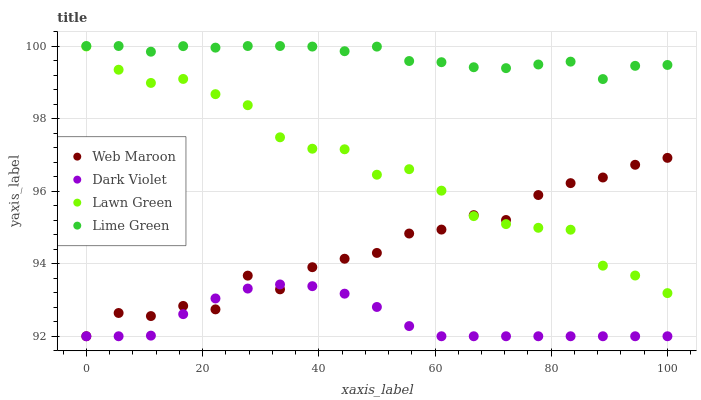Does Dark Violet have the minimum area under the curve?
Answer yes or no. Yes. Does Lime Green have the maximum area under the curve?
Answer yes or no. Yes. Does Lawn Green have the minimum area under the curve?
Answer yes or no. No. Does Lawn Green have the maximum area under the curve?
Answer yes or no. No. Is Dark Violet the smoothest?
Answer yes or no. Yes. Is Web Maroon the roughest?
Answer yes or no. Yes. Is Lawn Green the smoothest?
Answer yes or no. No. Is Lawn Green the roughest?
Answer yes or no. No. Does Web Maroon have the lowest value?
Answer yes or no. Yes. Does Lawn Green have the lowest value?
Answer yes or no. No. Does Lime Green have the highest value?
Answer yes or no. Yes. Does Lawn Green have the highest value?
Answer yes or no. No. Is Dark Violet less than Lime Green?
Answer yes or no. Yes. Is Lime Green greater than Dark Violet?
Answer yes or no. Yes. Does Web Maroon intersect Dark Violet?
Answer yes or no. Yes. Is Web Maroon less than Dark Violet?
Answer yes or no. No. Is Web Maroon greater than Dark Violet?
Answer yes or no. No. Does Dark Violet intersect Lime Green?
Answer yes or no. No. 